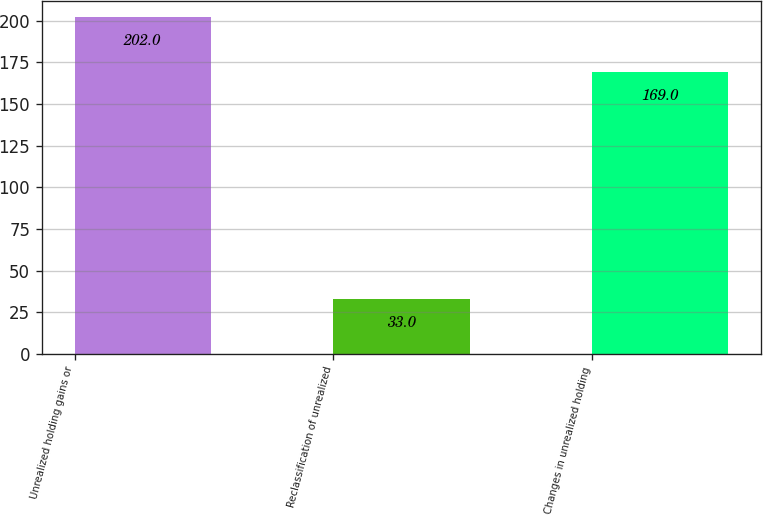<chart> <loc_0><loc_0><loc_500><loc_500><bar_chart><fcel>Unrealized holding gains or<fcel>Reclassification of unrealized<fcel>Changes in unrealized holding<nl><fcel>202<fcel>33<fcel>169<nl></chart> 